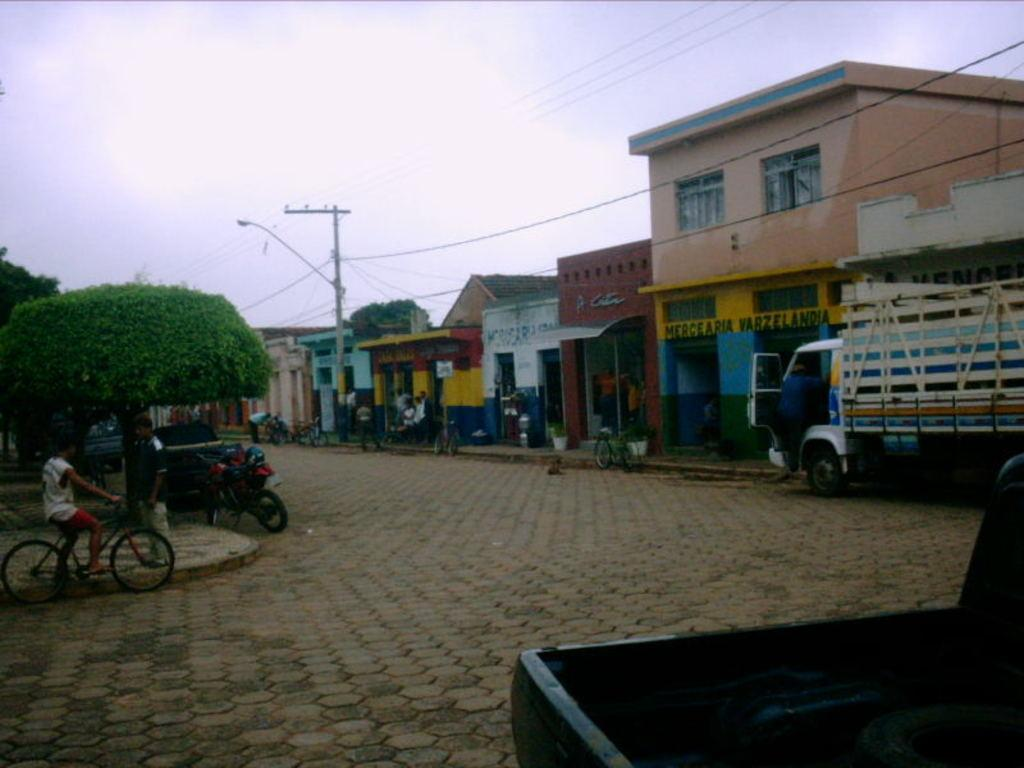What can be seen in the image that people use for walking? There is a path in the image that people use for walking. What is the child in the image riding? The child in the image is riding a cycle. What types of transportation are visible in the image? There are vehicles in the image. Who else can be seen in the image besides the child on the cycle? There are people in the image. What structures are visible in the image? There are buildings in the image. What type of vegetation is present in the image? There are trees in the image. Where is the plate located in the image? There is no plate present in the image. How can the people in the image be helped to reach their destination? The question assumes that the people in the image need help reaching their destination, which is not mentioned in the facts provided. The image only shows people, vehicles, and a child on a cycle, but it does not indicate any need for assistance. 